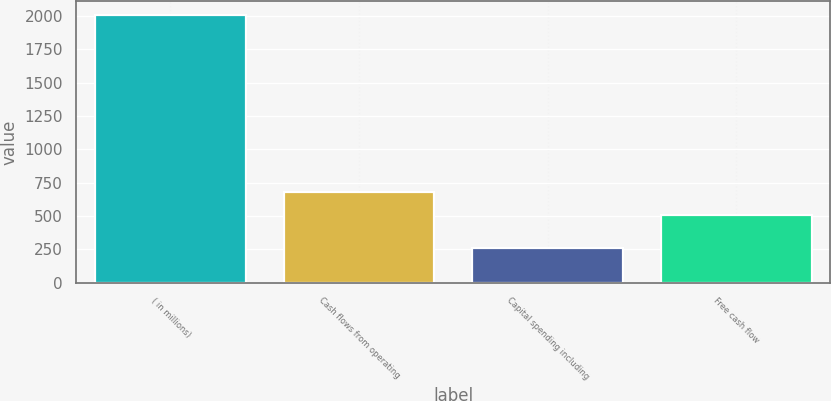<chart> <loc_0><loc_0><loc_500><loc_500><bar_chart><fcel>( in millions)<fcel>Cash flows from operating<fcel>Capital spending including<fcel>Free cash flow<nl><fcel>2010<fcel>680.86<fcel>259.4<fcel>505.8<nl></chart> 